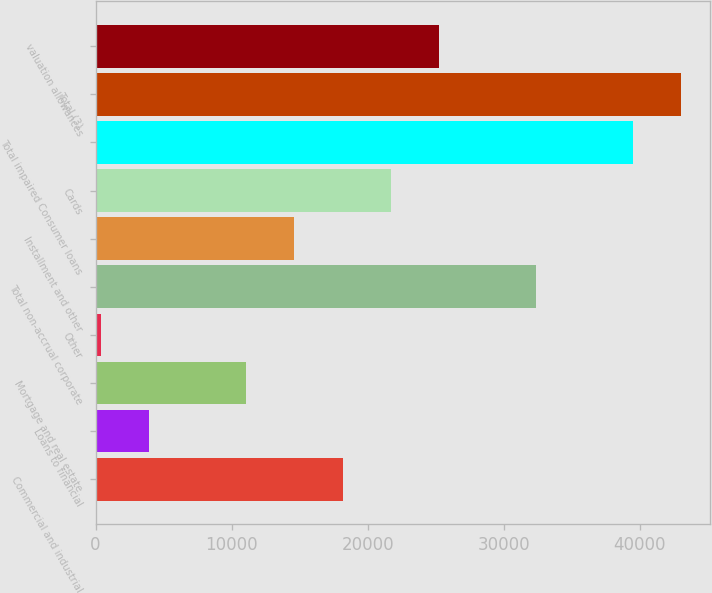Convert chart to OTSL. <chart><loc_0><loc_0><loc_500><loc_500><bar_chart><fcel>Commercial and industrial<fcel>Loans to financial<fcel>Mortgage and real estate<fcel>Other<fcel>Total non-accrual corporate<fcel>Installment and other<fcel>Cards<fcel>Total impaired Consumer loans<fcel>Total (3)<fcel>valuation allowances<nl><fcel>18169<fcel>3953.8<fcel>11061.4<fcel>400<fcel>32384.2<fcel>14615.2<fcel>21722.8<fcel>39491.8<fcel>43045.6<fcel>25276.6<nl></chart> 